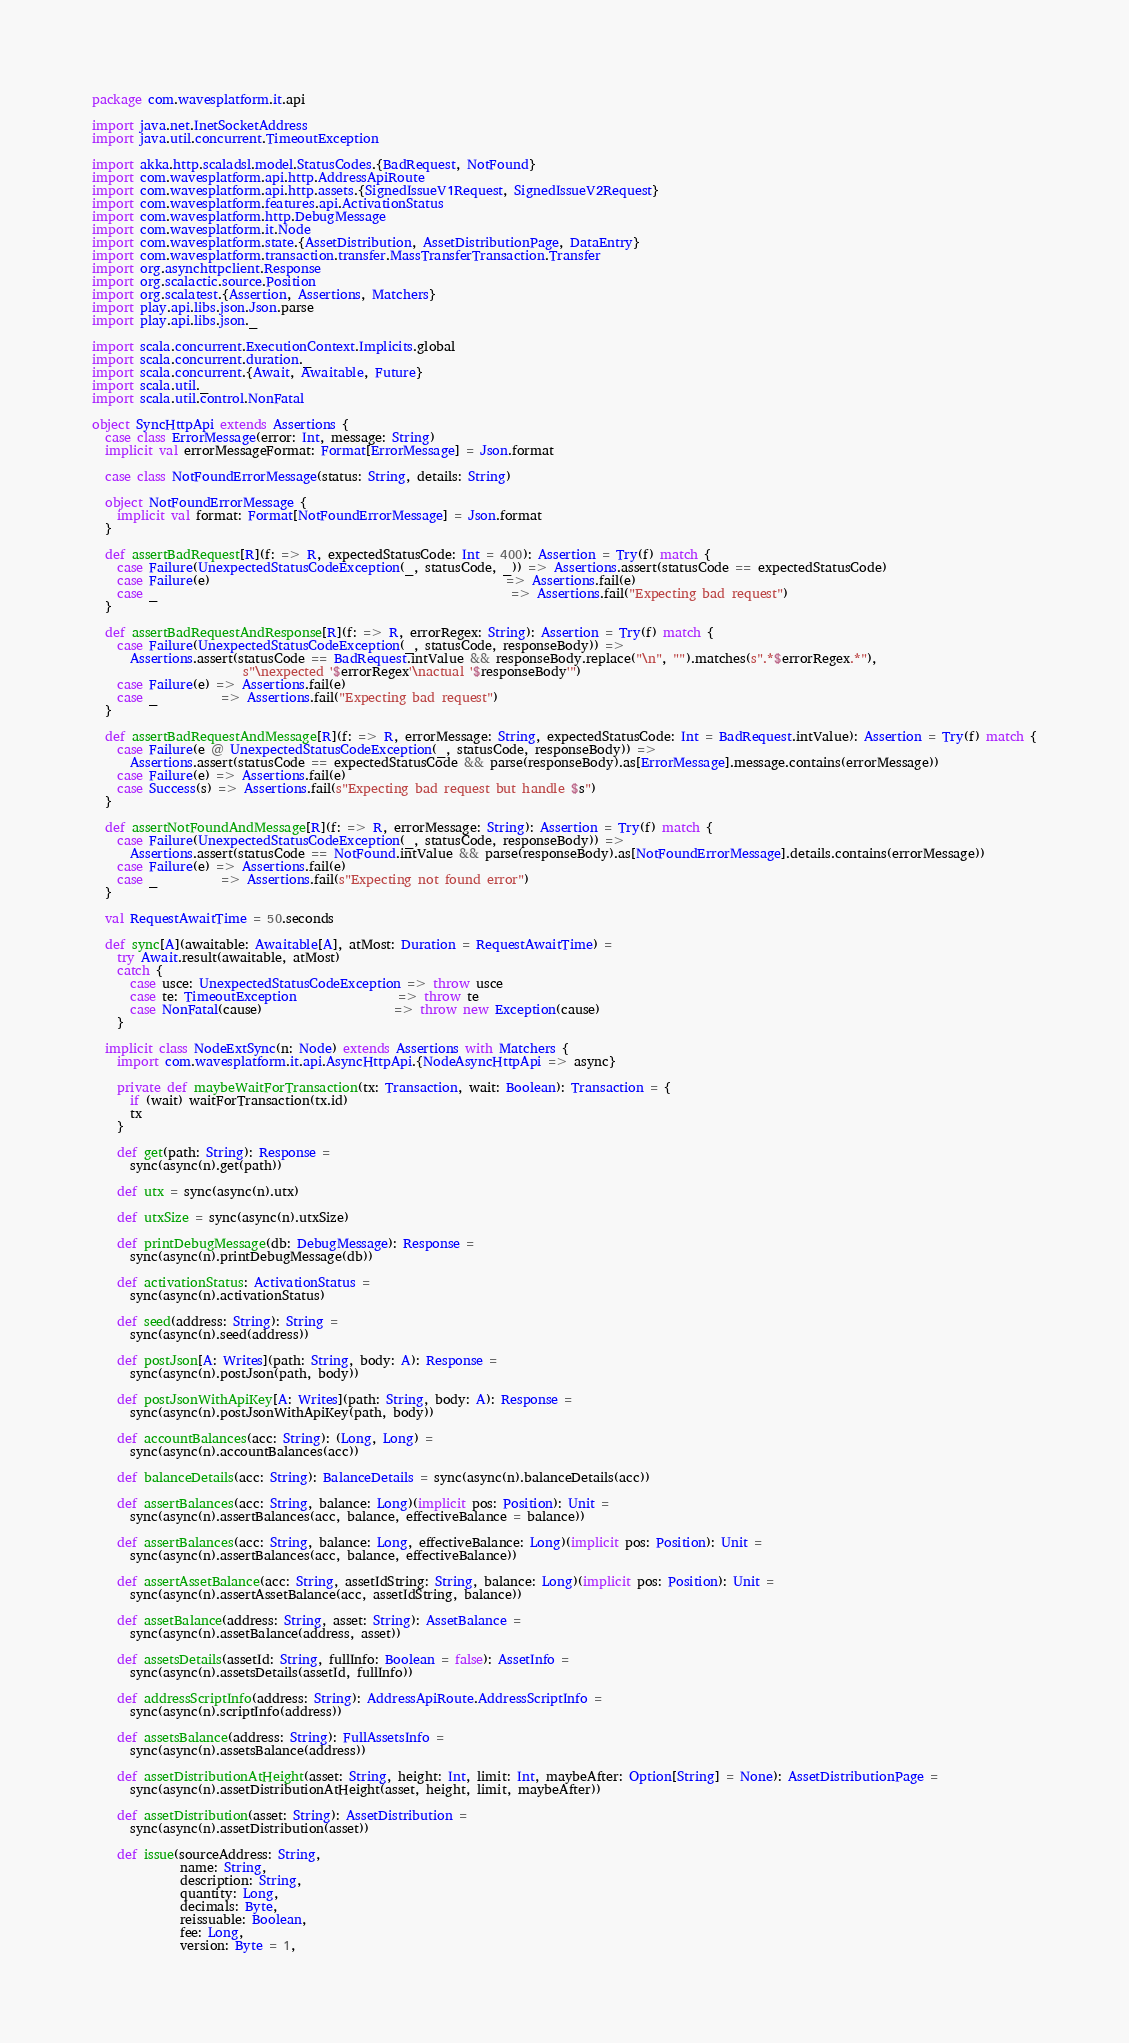Convert code to text. <code><loc_0><loc_0><loc_500><loc_500><_Scala_>package com.wavesplatform.it.api

import java.net.InetSocketAddress
import java.util.concurrent.TimeoutException

import akka.http.scaladsl.model.StatusCodes.{BadRequest, NotFound}
import com.wavesplatform.api.http.AddressApiRoute
import com.wavesplatform.api.http.assets.{SignedIssueV1Request, SignedIssueV2Request}
import com.wavesplatform.features.api.ActivationStatus
import com.wavesplatform.http.DebugMessage
import com.wavesplatform.it.Node
import com.wavesplatform.state.{AssetDistribution, AssetDistributionPage, DataEntry}
import com.wavesplatform.transaction.transfer.MassTransferTransaction.Transfer
import org.asynchttpclient.Response
import org.scalactic.source.Position
import org.scalatest.{Assertion, Assertions, Matchers}
import play.api.libs.json.Json.parse
import play.api.libs.json._

import scala.concurrent.ExecutionContext.Implicits.global
import scala.concurrent.duration._
import scala.concurrent.{Await, Awaitable, Future}
import scala.util._
import scala.util.control.NonFatal

object SyncHttpApi extends Assertions {
  case class ErrorMessage(error: Int, message: String)
  implicit val errorMessageFormat: Format[ErrorMessage] = Json.format

  case class NotFoundErrorMessage(status: String, details: String)

  object NotFoundErrorMessage {
    implicit val format: Format[NotFoundErrorMessage] = Json.format
  }

  def assertBadRequest[R](f: => R, expectedStatusCode: Int = 400): Assertion = Try(f) match {
    case Failure(UnexpectedStatusCodeException(_, statusCode, _)) => Assertions.assert(statusCode == expectedStatusCode)
    case Failure(e)                                               => Assertions.fail(e)
    case _                                                        => Assertions.fail("Expecting bad request")
  }

  def assertBadRequestAndResponse[R](f: => R, errorRegex: String): Assertion = Try(f) match {
    case Failure(UnexpectedStatusCodeException(_, statusCode, responseBody)) =>
      Assertions.assert(statusCode == BadRequest.intValue && responseBody.replace("\n", "").matches(s".*$errorRegex.*"),
                        s"\nexpected '$errorRegex'\nactual '$responseBody'")
    case Failure(e) => Assertions.fail(e)
    case _          => Assertions.fail("Expecting bad request")
  }

  def assertBadRequestAndMessage[R](f: => R, errorMessage: String, expectedStatusCode: Int = BadRequest.intValue): Assertion = Try(f) match {
    case Failure(e @ UnexpectedStatusCodeException(_, statusCode, responseBody)) =>
      Assertions.assert(statusCode == expectedStatusCode && parse(responseBody).as[ErrorMessage].message.contains(errorMessage))
    case Failure(e) => Assertions.fail(e)
    case Success(s) => Assertions.fail(s"Expecting bad request but handle $s")
  }

  def assertNotFoundAndMessage[R](f: => R, errorMessage: String): Assertion = Try(f) match {
    case Failure(UnexpectedStatusCodeException(_, statusCode, responseBody)) =>
      Assertions.assert(statusCode == NotFound.intValue && parse(responseBody).as[NotFoundErrorMessage].details.contains(errorMessage))
    case Failure(e) => Assertions.fail(e)
    case _          => Assertions.fail(s"Expecting not found error")
  }

  val RequestAwaitTime = 50.seconds

  def sync[A](awaitable: Awaitable[A], atMost: Duration = RequestAwaitTime) =
    try Await.result(awaitable, atMost)
    catch {
      case usce: UnexpectedStatusCodeException => throw usce
      case te: TimeoutException                => throw te
      case NonFatal(cause)                     => throw new Exception(cause)
    }

  implicit class NodeExtSync(n: Node) extends Assertions with Matchers {
    import com.wavesplatform.it.api.AsyncHttpApi.{NodeAsyncHttpApi => async}

    private def maybeWaitForTransaction(tx: Transaction, wait: Boolean): Transaction = {
      if (wait) waitForTransaction(tx.id)
      tx
    }

    def get(path: String): Response =
      sync(async(n).get(path))

    def utx = sync(async(n).utx)

    def utxSize = sync(async(n).utxSize)

    def printDebugMessage(db: DebugMessage): Response =
      sync(async(n).printDebugMessage(db))

    def activationStatus: ActivationStatus =
      sync(async(n).activationStatus)

    def seed(address: String): String =
      sync(async(n).seed(address))

    def postJson[A: Writes](path: String, body: A): Response =
      sync(async(n).postJson(path, body))

    def postJsonWithApiKey[A: Writes](path: String, body: A): Response =
      sync(async(n).postJsonWithApiKey(path, body))

    def accountBalances(acc: String): (Long, Long) =
      sync(async(n).accountBalances(acc))

    def balanceDetails(acc: String): BalanceDetails = sync(async(n).balanceDetails(acc))

    def assertBalances(acc: String, balance: Long)(implicit pos: Position): Unit =
      sync(async(n).assertBalances(acc, balance, effectiveBalance = balance))

    def assertBalances(acc: String, balance: Long, effectiveBalance: Long)(implicit pos: Position): Unit =
      sync(async(n).assertBalances(acc, balance, effectiveBalance))

    def assertAssetBalance(acc: String, assetIdString: String, balance: Long)(implicit pos: Position): Unit =
      sync(async(n).assertAssetBalance(acc, assetIdString, balance))

    def assetBalance(address: String, asset: String): AssetBalance =
      sync(async(n).assetBalance(address, asset))

    def assetsDetails(assetId: String, fullInfo: Boolean = false): AssetInfo =
      sync(async(n).assetsDetails(assetId, fullInfo))

    def addressScriptInfo(address: String): AddressApiRoute.AddressScriptInfo =
      sync(async(n).scriptInfo(address))

    def assetsBalance(address: String): FullAssetsInfo =
      sync(async(n).assetsBalance(address))

    def assetDistributionAtHeight(asset: String, height: Int, limit: Int, maybeAfter: Option[String] = None): AssetDistributionPage =
      sync(async(n).assetDistributionAtHeight(asset, height, limit, maybeAfter))

    def assetDistribution(asset: String): AssetDistribution =
      sync(async(n).assetDistribution(asset))

    def issue(sourceAddress: String,
              name: String,
              description: String,
              quantity: Long,
              decimals: Byte,
              reissuable: Boolean,
              fee: Long,
              version: Byte = 1,</code> 